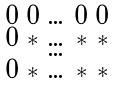Convert formula to latex. <formula><loc_0><loc_0><loc_500><loc_500>\begin{smallmatrix} 0 & 0 & \dots & 0 & 0 \\ 0 & * & \dots & * & * \\ & & \dots & & \\ 0 & * & \dots & * & * \\ \end{smallmatrix}</formula> 